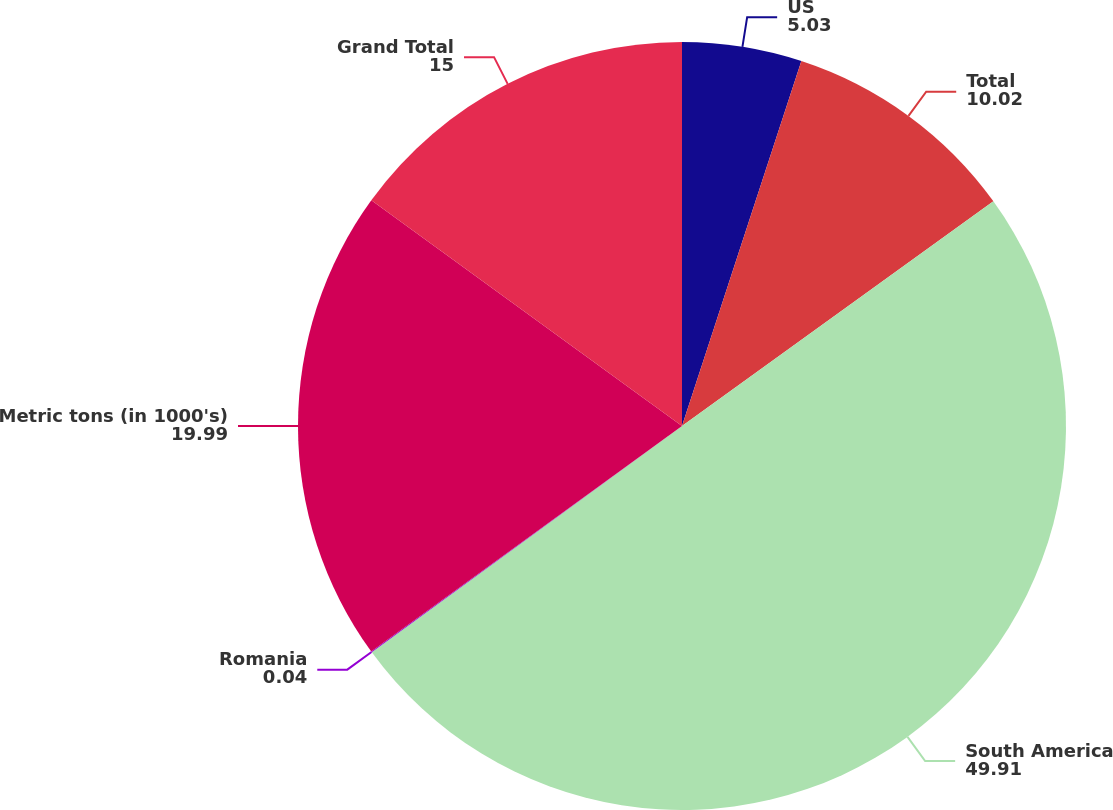Convert chart to OTSL. <chart><loc_0><loc_0><loc_500><loc_500><pie_chart><fcel>US<fcel>Total<fcel>South America<fcel>Romania<fcel>Metric tons (in 1000's)<fcel>Grand Total<nl><fcel>5.03%<fcel>10.02%<fcel>49.91%<fcel>0.04%<fcel>19.99%<fcel>15.0%<nl></chart> 